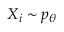<formula> <loc_0><loc_0><loc_500><loc_500>X _ { i } \sim p _ { \theta }</formula> 